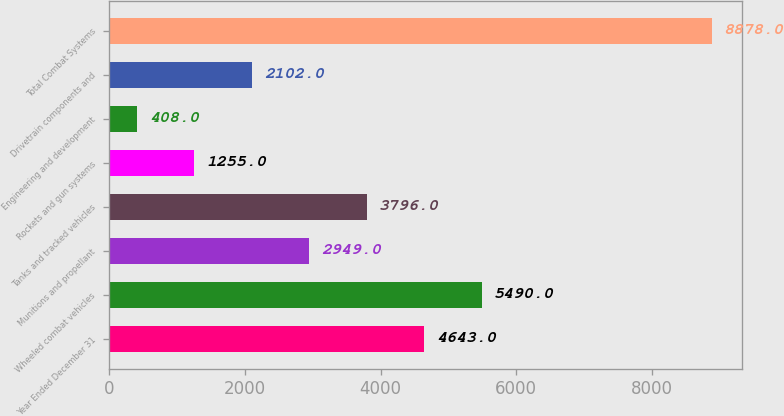Convert chart to OTSL. <chart><loc_0><loc_0><loc_500><loc_500><bar_chart><fcel>Year Ended December 31<fcel>Wheeled combat vehicles<fcel>Munitions and propellant<fcel>Tanks and tracked vehicles<fcel>Rockets and gun systems<fcel>Engineering and development<fcel>Drivetrain components and<fcel>Total Combat Systems<nl><fcel>4643<fcel>5490<fcel>2949<fcel>3796<fcel>1255<fcel>408<fcel>2102<fcel>8878<nl></chart> 